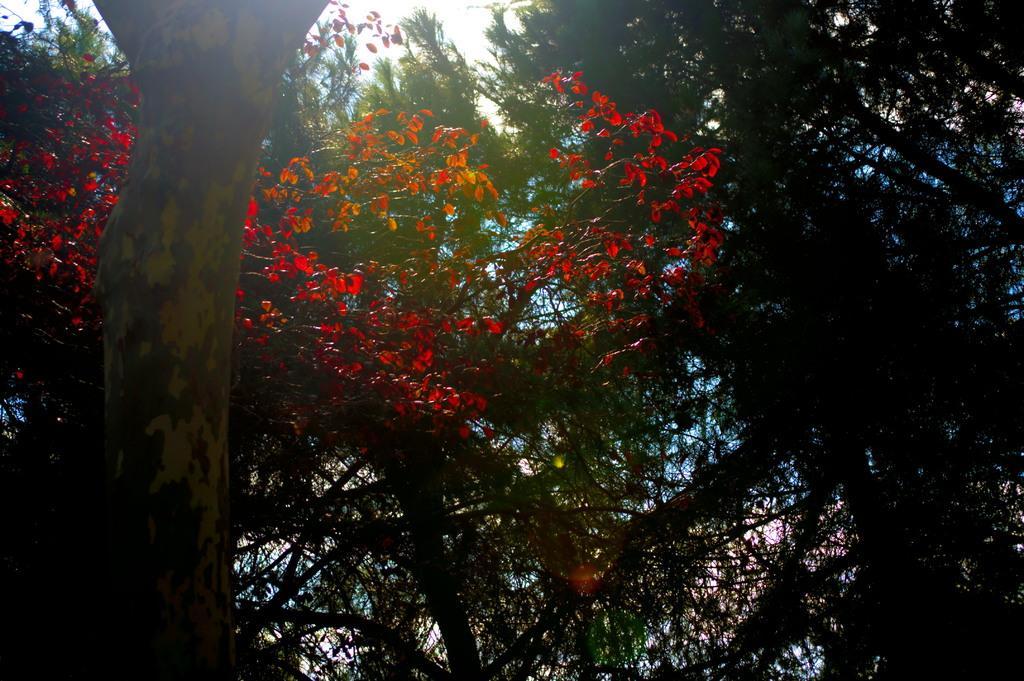Please provide a concise description of this image. In this image, there are a few trees. We can also see the sky. 